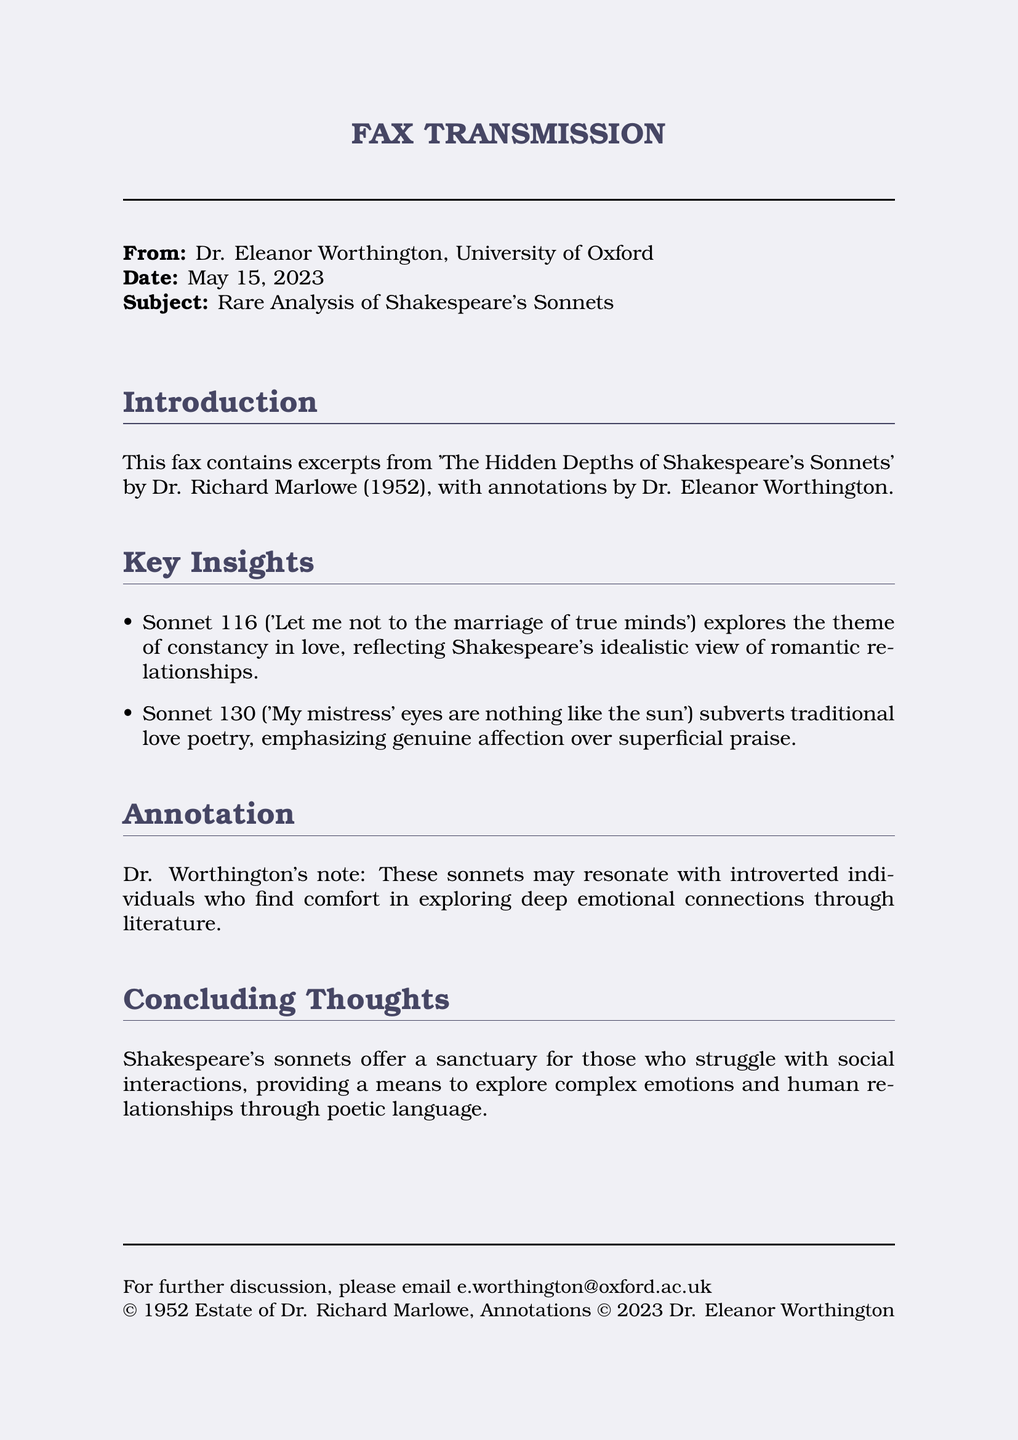What is the name of the author of the analysis? The author's name is mentioned in the document as Dr. Richard Marlowe.
Answer: Dr. Richard Marlowe What is the year of publication of the analysis? The publication year of the analysis is stated in the document as 1952.
Answer: 1952 Who is the sender of the fax? The sender's name is provided in the document.
Answer: Dr. Eleanor Worthington What is the email address for further discussion? The document includes contact information for further discussion, which is an email address.
Answer: e.worthington@oxford.ac.uk Which sonnet discusses the theme of constancy in love? The document references a specific sonnet that explores the theme of constancy.
Answer: Sonnet 116 Which sonnet subverts traditional love poetry? The document identifies a sonnet that contrasts usual love poetry conventions.
Answer: Sonnet 130 What does Dr. Worthington's annotation suggest? Dr. Worthington's note explains the potential connection with a certain type of individual.
Answer: Comfort in exploring deep emotional connections through literature What is the date of the fax? The specific date of the fax is listed in the document.
Answer: May 15, 2023 What type of document is this? The format of the document is specified at the beginning as a specific type.
Answer: FAX TRANSMISSION In which university does Dr. Eleanor Worthington work? The university affiliation of the sender is provided in the document.
Answer: University of Oxford 